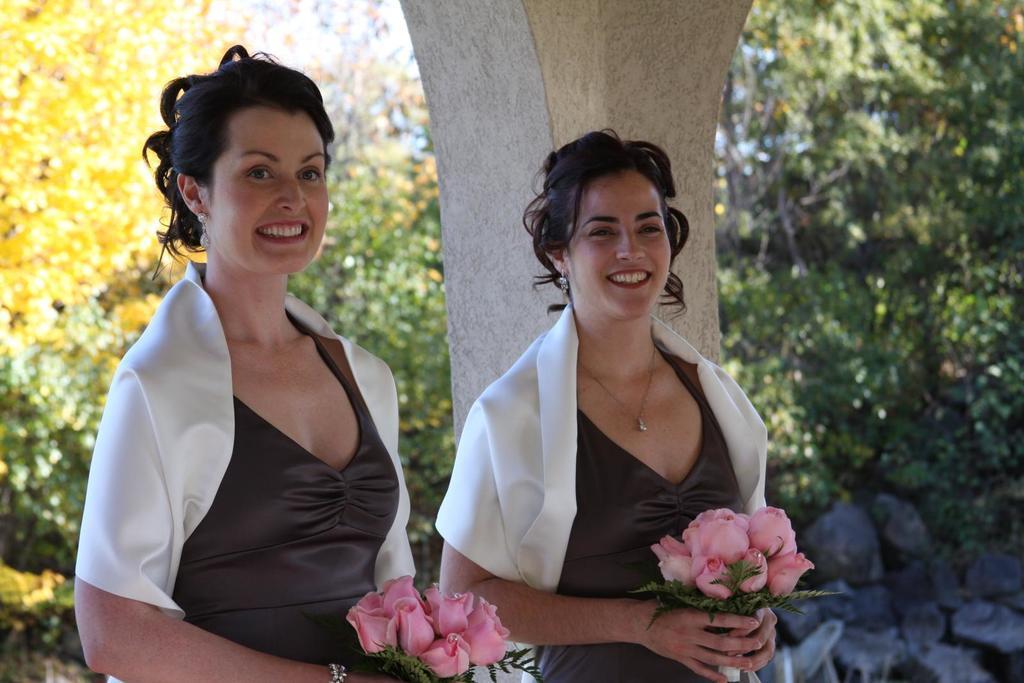Could you give a brief overview of what you see in this image? In this image there are two females. They are holding flower bouquet. There is a pillar. There are trees in the background. 